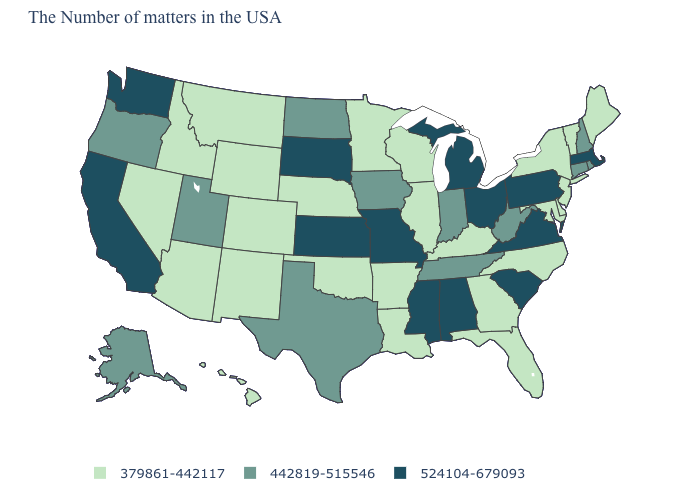Which states have the lowest value in the South?
Quick response, please. Delaware, Maryland, North Carolina, Florida, Georgia, Kentucky, Louisiana, Arkansas, Oklahoma. What is the value of Nebraska?
Answer briefly. 379861-442117. What is the lowest value in the USA?
Write a very short answer. 379861-442117. Is the legend a continuous bar?
Keep it brief. No. Name the states that have a value in the range 379861-442117?
Write a very short answer. Maine, Vermont, New York, New Jersey, Delaware, Maryland, North Carolina, Florida, Georgia, Kentucky, Wisconsin, Illinois, Louisiana, Arkansas, Minnesota, Nebraska, Oklahoma, Wyoming, Colorado, New Mexico, Montana, Arizona, Idaho, Nevada, Hawaii. Does Minnesota have a higher value than Maine?
Answer briefly. No. Among the states that border Wisconsin , does Michigan have the lowest value?
Short answer required. No. How many symbols are there in the legend?
Answer briefly. 3. Name the states that have a value in the range 379861-442117?
Be succinct. Maine, Vermont, New York, New Jersey, Delaware, Maryland, North Carolina, Florida, Georgia, Kentucky, Wisconsin, Illinois, Louisiana, Arkansas, Minnesota, Nebraska, Oklahoma, Wyoming, Colorado, New Mexico, Montana, Arizona, Idaho, Nevada, Hawaii. What is the value of West Virginia?
Short answer required. 442819-515546. How many symbols are there in the legend?
Give a very brief answer. 3. Is the legend a continuous bar?
Concise answer only. No. Among the states that border Oklahoma , which have the lowest value?
Give a very brief answer. Arkansas, Colorado, New Mexico. Name the states that have a value in the range 379861-442117?
Quick response, please. Maine, Vermont, New York, New Jersey, Delaware, Maryland, North Carolina, Florida, Georgia, Kentucky, Wisconsin, Illinois, Louisiana, Arkansas, Minnesota, Nebraska, Oklahoma, Wyoming, Colorado, New Mexico, Montana, Arizona, Idaho, Nevada, Hawaii. Name the states that have a value in the range 379861-442117?
Answer briefly. Maine, Vermont, New York, New Jersey, Delaware, Maryland, North Carolina, Florida, Georgia, Kentucky, Wisconsin, Illinois, Louisiana, Arkansas, Minnesota, Nebraska, Oklahoma, Wyoming, Colorado, New Mexico, Montana, Arizona, Idaho, Nevada, Hawaii. 